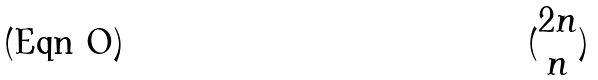<formula> <loc_0><loc_0><loc_500><loc_500>( \begin{matrix} 2 n \\ n \end{matrix} )</formula> 